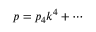Convert formula to latex. <formula><loc_0><loc_0><loc_500><loc_500>p = p _ { 4 } k ^ { 4 } + \cdots</formula> 